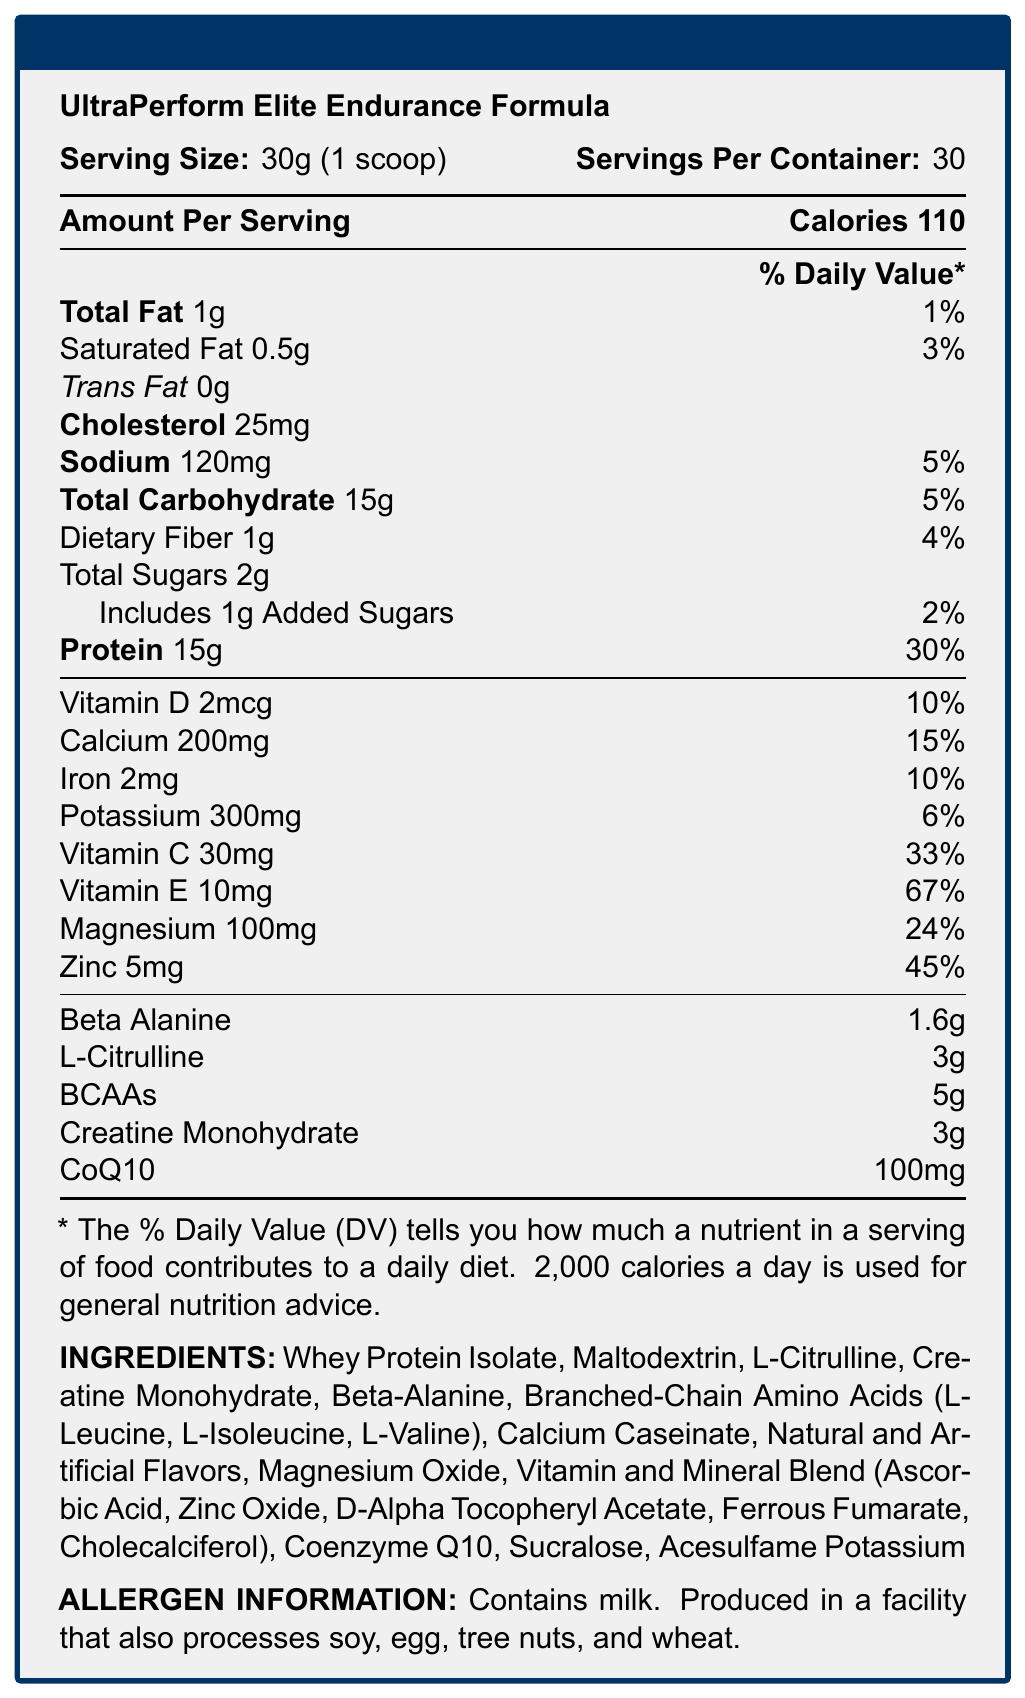what is the serving size for UltraPerform Elite Endurance Formula? The serving size is specified as 30g, equivalent to 1 scoop, in the first line of the nutrition information.
Answer: 30g (1 scoop) How many calories are in one serving of UltraPerform Elite Endurance Formula? The document states that each serving contains 110 calories.
Answer: 110 calories Which nutrient has the highest % Daily Value per serving? The % Daily Value is listed next to each nutrient, with protein showing the highest at 30%.
Answer: Protein (30%) How many grams of total carbohydrates are in one serving? The amount of total carbohydrates per serving is listed as 15g.
Answer: 15g What are the listed vitamins and minerals included in this supplement? These micronutrients are listed with their amounts and % Daily Values in the document.
Answer: Vitamin D, Calcium, Iron, Potassium, Vitamin C, Vitamin E, Magnesium, Zinc Which of the following is NOT an ingredient in the UltraPerform Elite Endurance Formula? A. Whey Protein Isolate B. L-Glutamine C. Creatine Monohydrate D. Sucralose L-Glutamine is not listed under the ingredients section in the document.
Answer: B. L-Glutamine What are the benefits associated with L-Citrulline and Beta-Alanine according to the expert insights? A. Enhance nitric oxide production and buffer lactic acid B. Improve digestion and reduce inflammation C. Increase appetite and promote muscle growth According to the expert insights, L-Citrulline and Beta-Alanine work synergistically to enhance nitric oxide production and buffer lactic acid, potentially improving exercise performance and delaying fatigue.
Answer: A. Enhance nitric oxide production and buffer lactic acid Does this product contain any allergen warnings? The allergen information states that the product contains milk and is produced in a facility that also processes soy, egg, tree nuts, and wheat.
Answer: Yes Summarize the main purpose of UltraPerform Elite Endurance Formula according to the document. The summary captures the main purpose as described by the nutrition facts, ingredients, and expert insights.
Answer: The UltraPerform Elite Endurance Formula is designed to support high-intensity endurance activities and promote muscle recovery through a balanced nutrient profile including proteins, carbohydrates, vitamins, minerals, and performance-enhancing ingredients such as L-Citrulline and Beta-Alanine. What is the daily value percentage of iron in one serving? The daily value percentage for iron is listed as 10%.
Answer: 10% How many servings are in one container of UltraPerform Elite Endurance Formula? The document mentions that there are 30 servings per container.
Answer: 30 servings What is the amount of creatine monohydrate in one serving? The amount of creatine monohydrate per serving is listed as 3g.
Answer: 3g Which one of the following ingredients is present in the product in the smallest amount? A. CoQ10 B. Magnesium C. Potassium D. Calcium CoQ10 is present in the amount of 100mg, which is relatively small compared to other ingredients like potassium (300mg) or calcium (200mg).
Answer: A. CoQ10 Which nutrient(s) primarily contribute to muscle protein synthesis according to the expert insights? The expert insights mention that the balanced ratio of fast-acting whey protein and slow-release casein provides sustained amino acid delivery for optimal muscle protein synthesis.
Answer: Whey Protein Isolate, Calcium Caseinate What is the total weight of the supplement if it contains 30 servings? Each serving is 30g, so 30 servings amount to 30g * 30 = 900g.
Answer: 900g Is there enough information to determine if UltraPerform Elite Endurance Formula is gluten-free? The document only mentions allergen information related to milk, soy, egg, tree nuts, and wheat processing but does not provide specific information about the gluten content.
Answer: Not enough information 